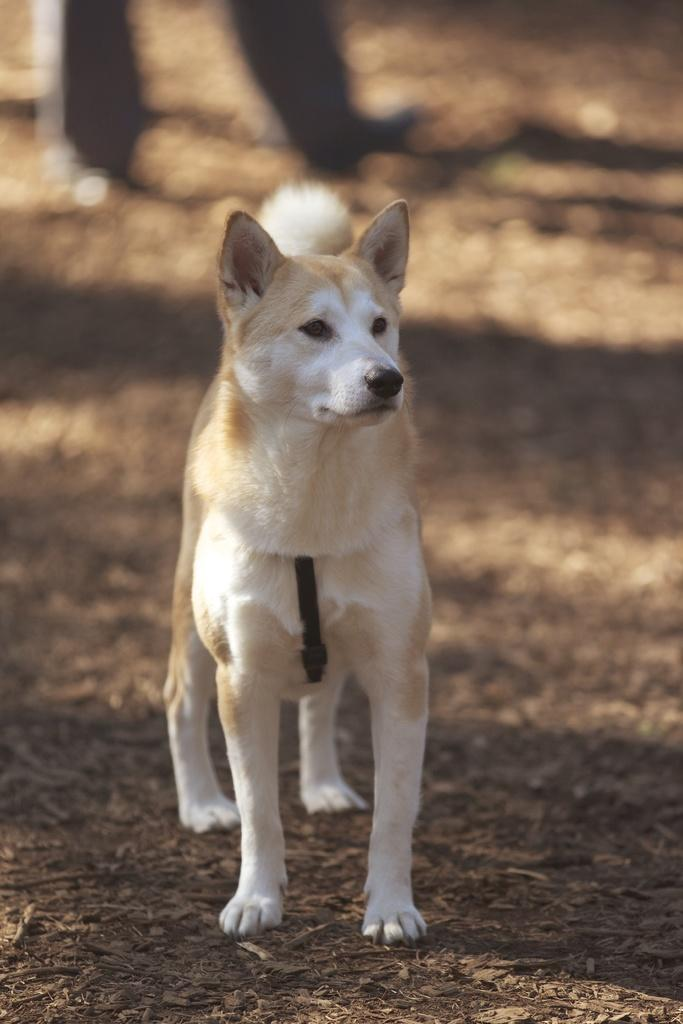What type of animal is present in the image? There is a dog standing on the land in the image. What other living being is present in the image? There is a person standing on the land in the image. What type of vest can be seen on the dog in the image? There is no vest present on the dog in the image. What type of arch is visible in the background of the image? There is no arch visible in the image; it only features the dog and the person standing on the land. 